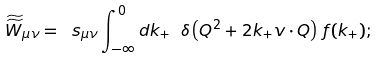<formula> <loc_0><loc_0><loc_500><loc_500>\widetilde { \widetilde { W } } _ { \mu \nu } = \ s _ { \mu \nu } \int _ { - \infty } ^ { 0 } d k _ { + } \ \delta \left ( Q ^ { 2 } + 2 k _ { + } v \cdot Q \right ) \, f ( k _ { + } ) ;</formula> 